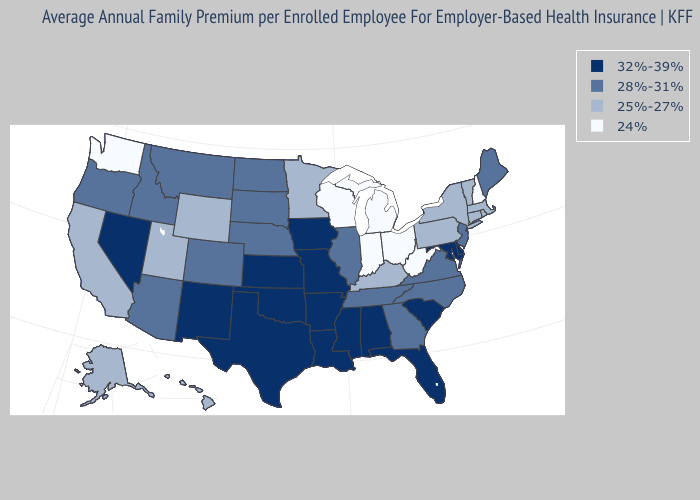Name the states that have a value in the range 25%-27%?
Quick response, please. Alaska, California, Connecticut, Hawaii, Kentucky, Massachusetts, Minnesota, New York, Pennsylvania, Rhode Island, Utah, Vermont, Wyoming. Does Tennessee have a higher value than Virginia?
Keep it brief. No. Which states hav the highest value in the Northeast?
Give a very brief answer. Maine, New Jersey. What is the value of Missouri?
Keep it brief. 32%-39%. What is the highest value in the USA?
Quick response, please. 32%-39%. Which states have the highest value in the USA?
Be succinct. Alabama, Arkansas, Delaware, Florida, Iowa, Kansas, Louisiana, Maryland, Mississippi, Missouri, Nevada, New Mexico, Oklahoma, South Carolina, Texas. What is the highest value in the South ?
Answer briefly. 32%-39%. Is the legend a continuous bar?
Concise answer only. No. Among the states that border South Dakota , does Iowa have the highest value?
Give a very brief answer. Yes. Which states have the lowest value in the Northeast?
Be succinct. New Hampshire. Is the legend a continuous bar?
Concise answer only. No. What is the value of Idaho?
Answer briefly. 28%-31%. Among the states that border New Mexico , which have the highest value?
Keep it brief. Oklahoma, Texas. What is the value of New York?
Keep it brief. 25%-27%. What is the value of South Carolina?
Be succinct. 32%-39%. 